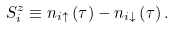<formula> <loc_0><loc_0><loc_500><loc_500>S _ { i } ^ { z } \equiv n _ { i \uparrow } \left ( \tau \right ) - n _ { i \downarrow } \left ( \tau \right ) .</formula> 